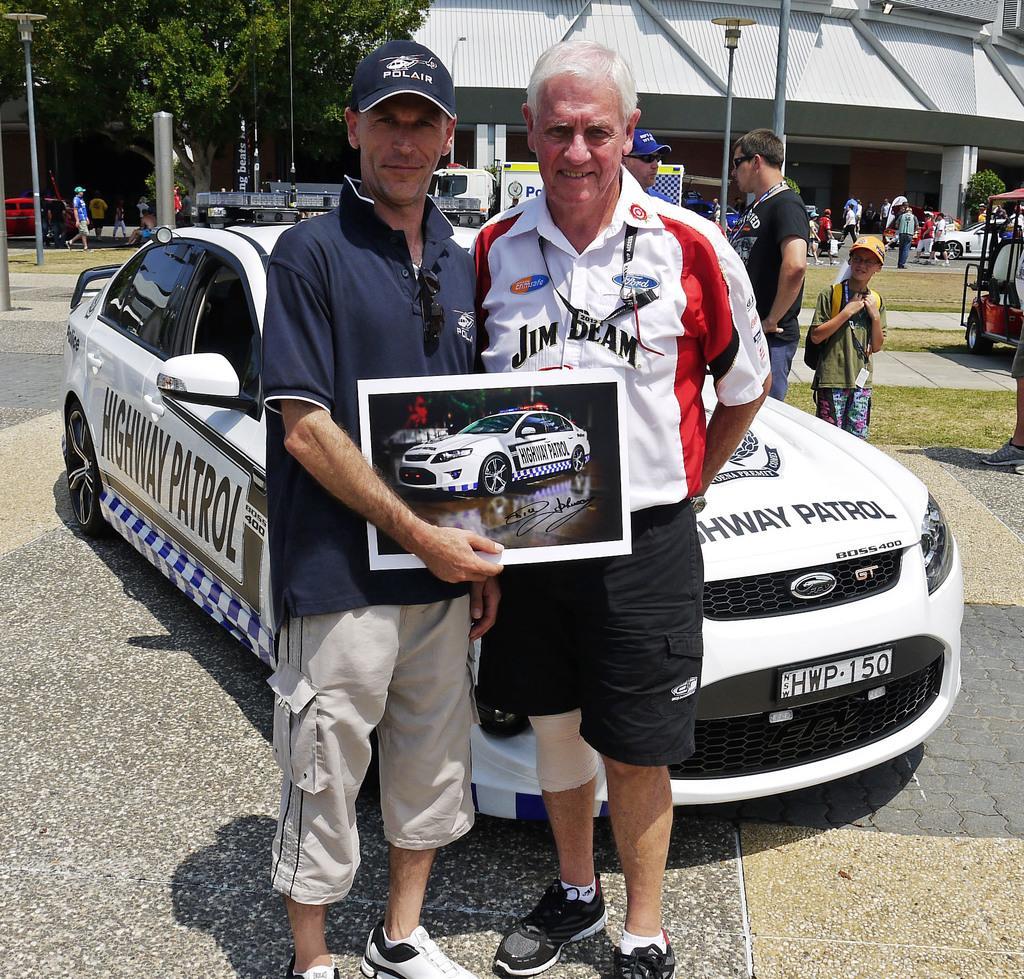Can you describe this image briefly? In this image, we can see a man holding a board with a picture and standing. He is wearing a cap and smiling. Beside him there is another person standing and smiling. Behind them there is a car on the path. In the background, there are people, poles, street lights, grass, trees, vehicles, walkways, building, wall, pillars, banners and few objects. 